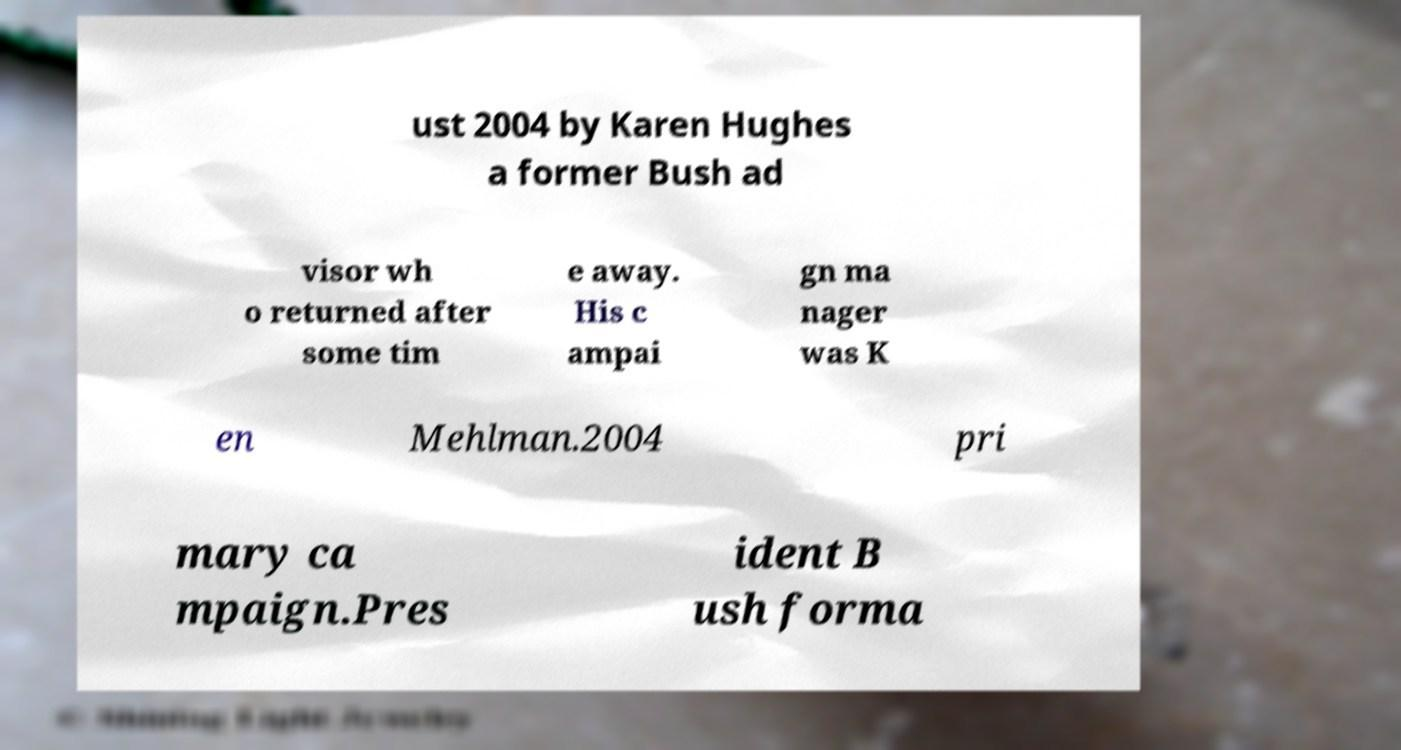There's text embedded in this image that I need extracted. Can you transcribe it verbatim? ust 2004 by Karen Hughes a former Bush ad visor wh o returned after some tim e away. His c ampai gn ma nager was K en Mehlman.2004 pri mary ca mpaign.Pres ident B ush forma 